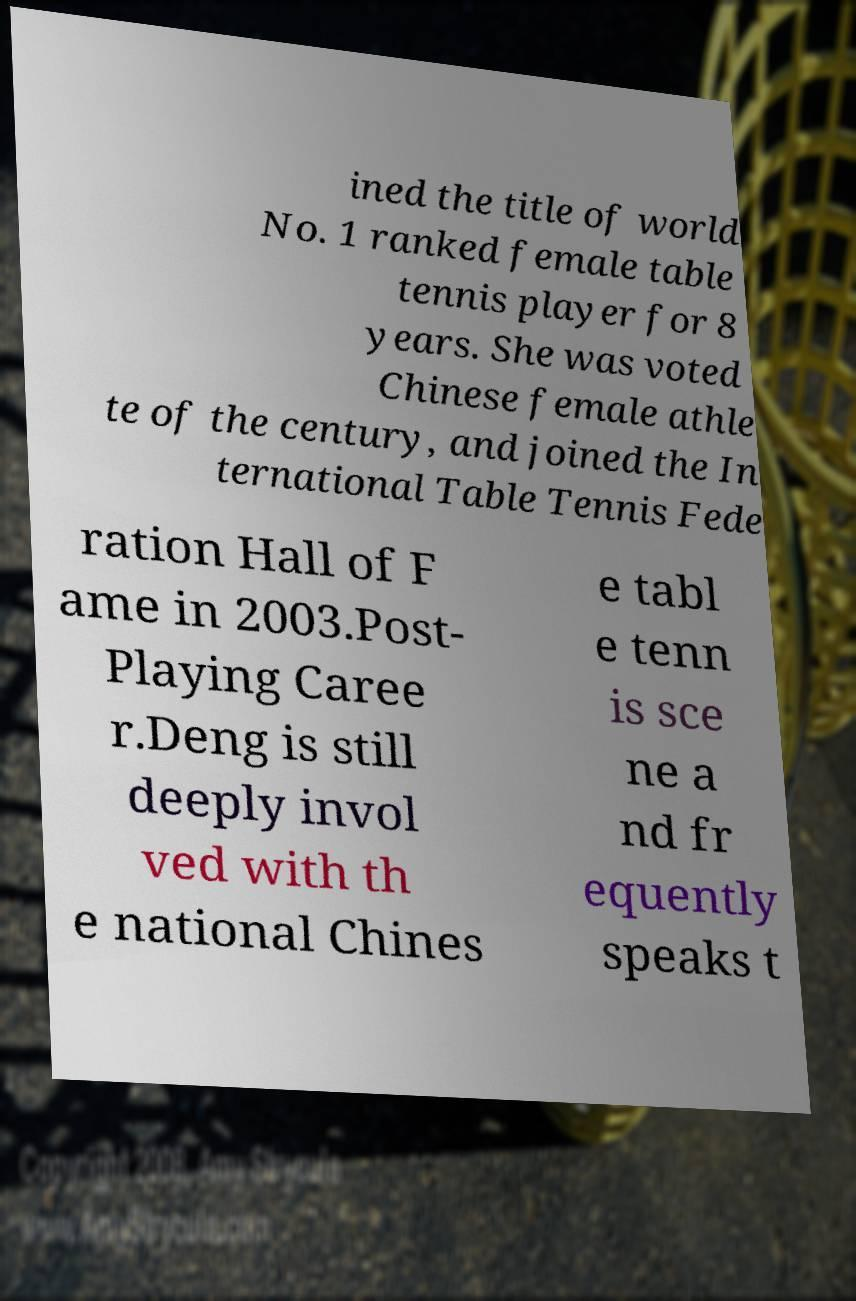Can you accurately transcribe the text from the provided image for me? ined the title of world No. 1 ranked female table tennis player for 8 years. She was voted Chinese female athle te of the century, and joined the In ternational Table Tennis Fede ration Hall of F ame in 2003.Post- Playing Caree r.Deng is still deeply invol ved with th e national Chines e tabl e tenn is sce ne a nd fr equently speaks t 